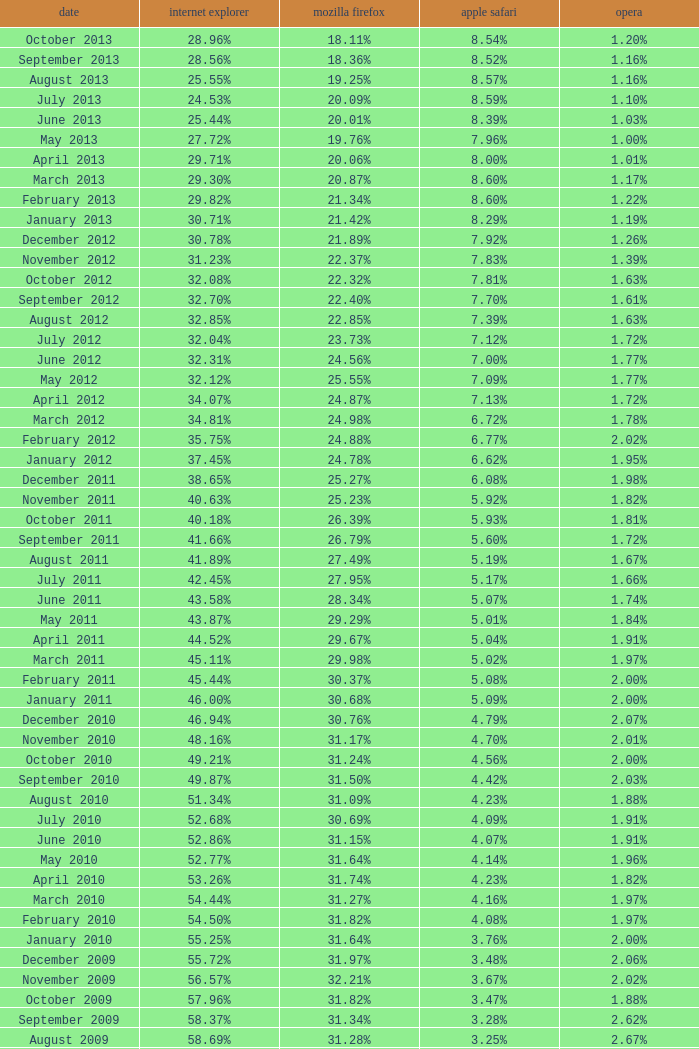What percentage of browsers were using Internet Explorer during the period in which 27.85% were using Firefox? 64.43%. 